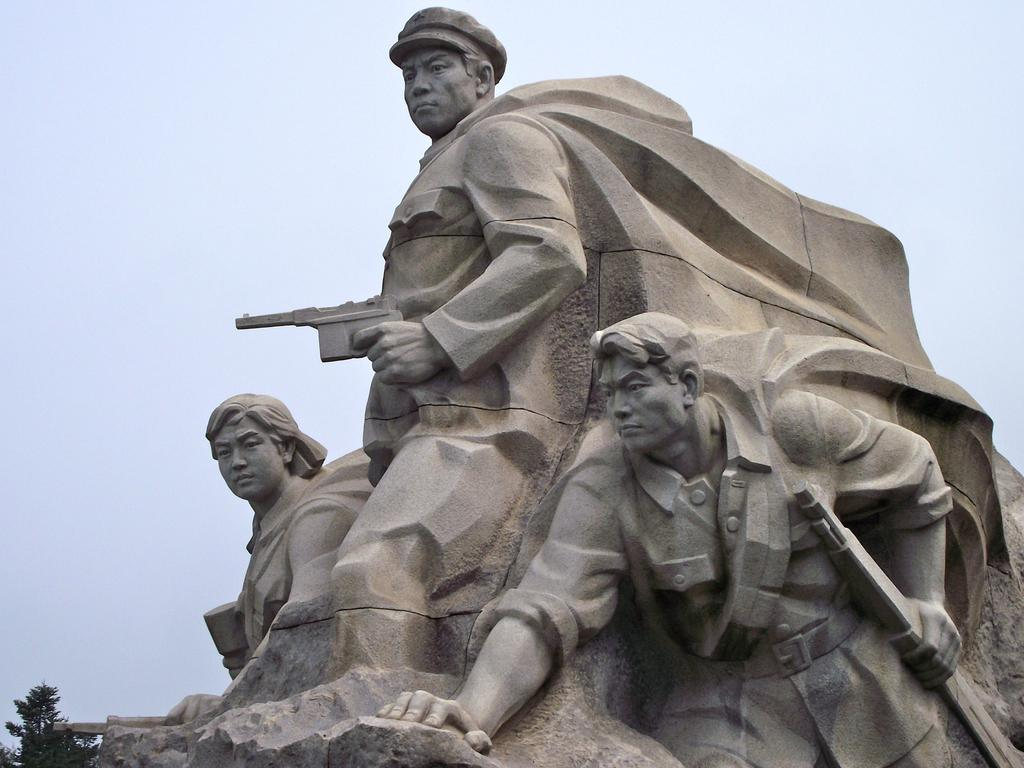What is the main subject of the image? There is a sculpture in the image. What can be seen in the background of the image? There is a sky visible in the background of the image. What suggestions does the sculpture have for improving digestion? The sculpture does not provide suggestions for improving digestion, as it is an inanimate object and cannot communicate or offer advice. 